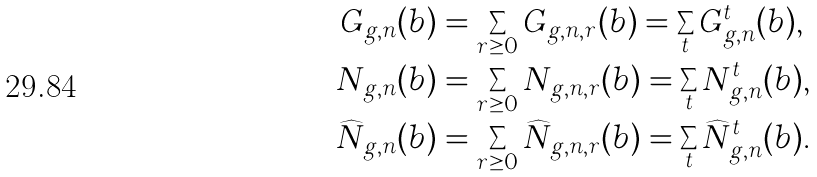Convert formula to latex. <formula><loc_0><loc_0><loc_500><loc_500>G _ { g , n } ( { b } ) & = \sum _ { r \geq 0 } G _ { g , n , r } ( { b } ) = \sum _ { t } G _ { g , n } ^ { t } ( { b } ) , \\ N _ { g , n } ( { b } ) & = \sum _ { r \geq 0 } N _ { g , n , r } ( { b } ) = \sum _ { t } N _ { g , n } ^ { t } ( { b } ) , \\ \widehat { N } _ { g , n } ( { b } ) & = \sum _ { r \geq 0 } \widehat { N } _ { g , n , r } ( { b } ) = \sum _ { t } \widehat { N } _ { g , n } ^ { t } ( { b } ) .</formula> 